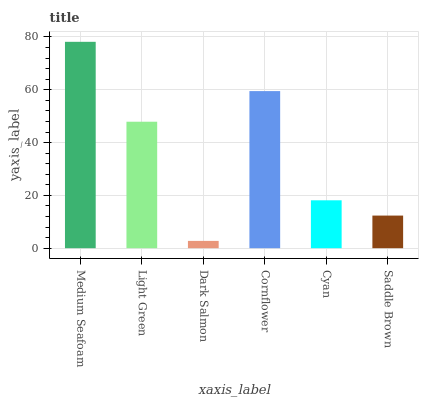Is Dark Salmon the minimum?
Answer yes or no. Yes. Is Medium Seafoam the maximum?
Answer yes or no. Yes. Is Light Green the minimum?
Answer yes or no. No. Is Light Green the maximum?
Answer yes or no. No. Is Medium Seafoam greater than Light Green?
Answer yes or no. Yes. Is Light Green less than Medium Seafoam?
Answer yes or no. Yes. Is Light Green greater than Medium Seafoam?
Answer yes or no. No. Is Medium Seafoam less than Light Green?
Answer yes or no. No. Is Light Green the high median?
Answer yes or no. Yes. Is Cyan the low median?
Answer yes or no. Yes. Is Cyan the high median?
Answer yes or no. No. Is Dark Salmon the low median?
Answer yes or no. No. 